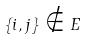<formula> <loc_0><loc_0><loc_500><loc_500>\{ i , j \} \notin E</formula> 